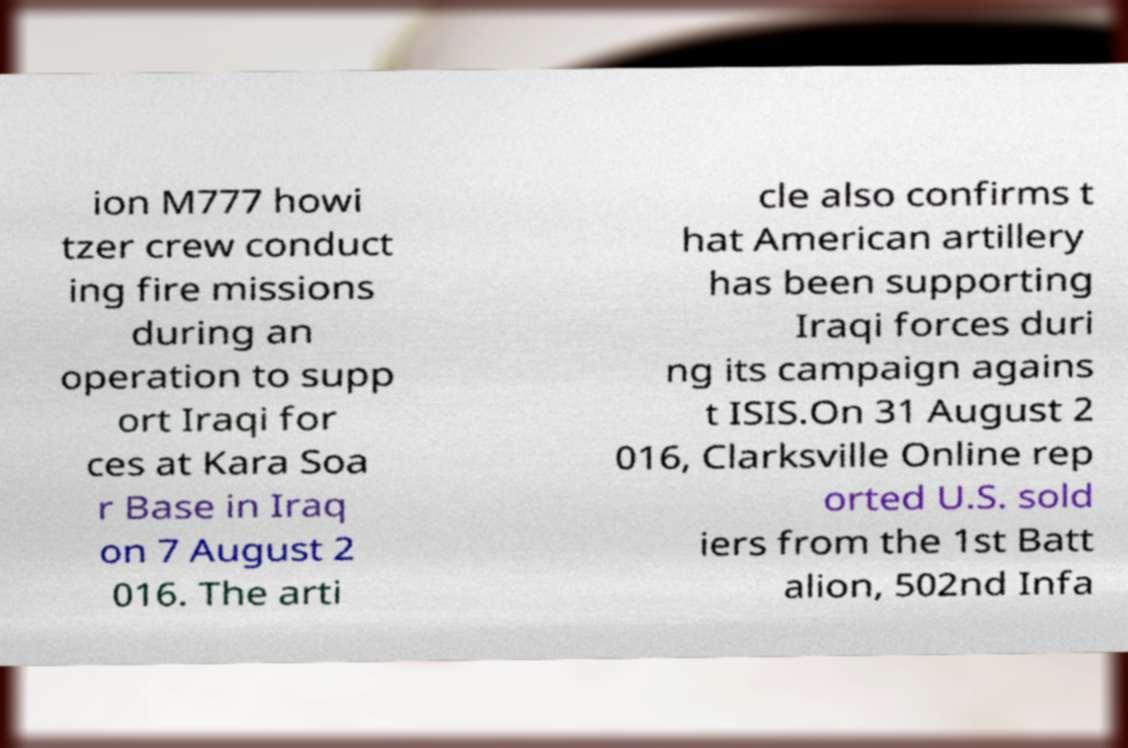Please identify and transcribe the text found in this image. ion M777 howi tzer crew conduct ing fire missions during an operation to supp ort Iraqi for ces at Kara Soa r Base in Iraq on 7 August 2 016. The arti cle also confirms t hat American artillery has been supporting Iraqi forces duri ng its campaign agains t ISIS.On 31 August 2 016, Clarksville Online rep orted U.S. sold iers from the 1st Batt alion, 502nd Infa 